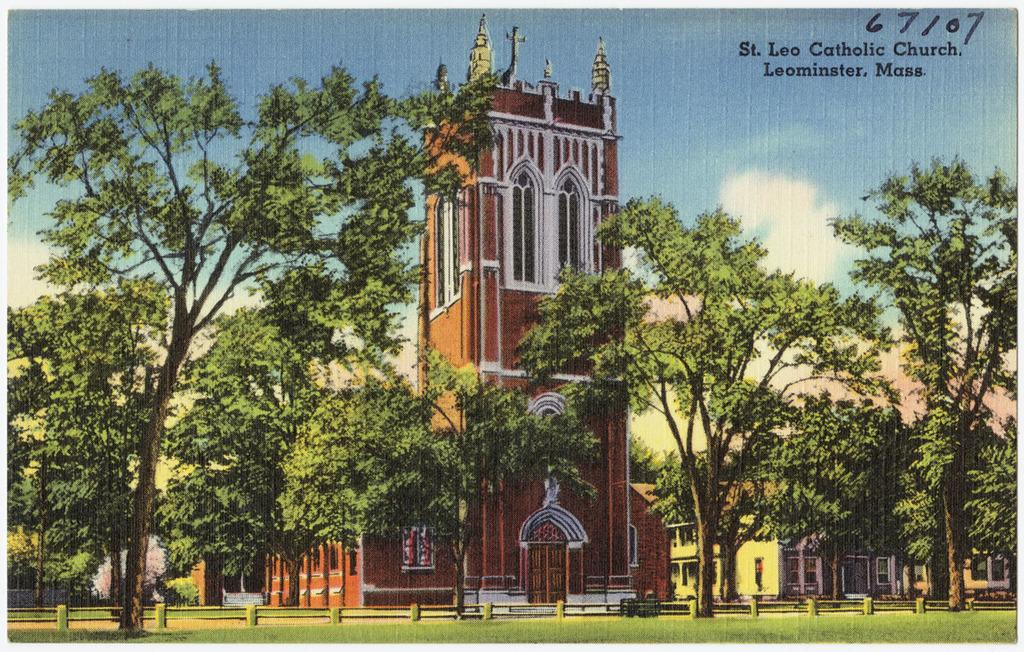Provide a one-sentence caption for the provided image. A postcard illustration of a church that says St. Lee Catholic Church, Leominster, Mass. in the corner. 